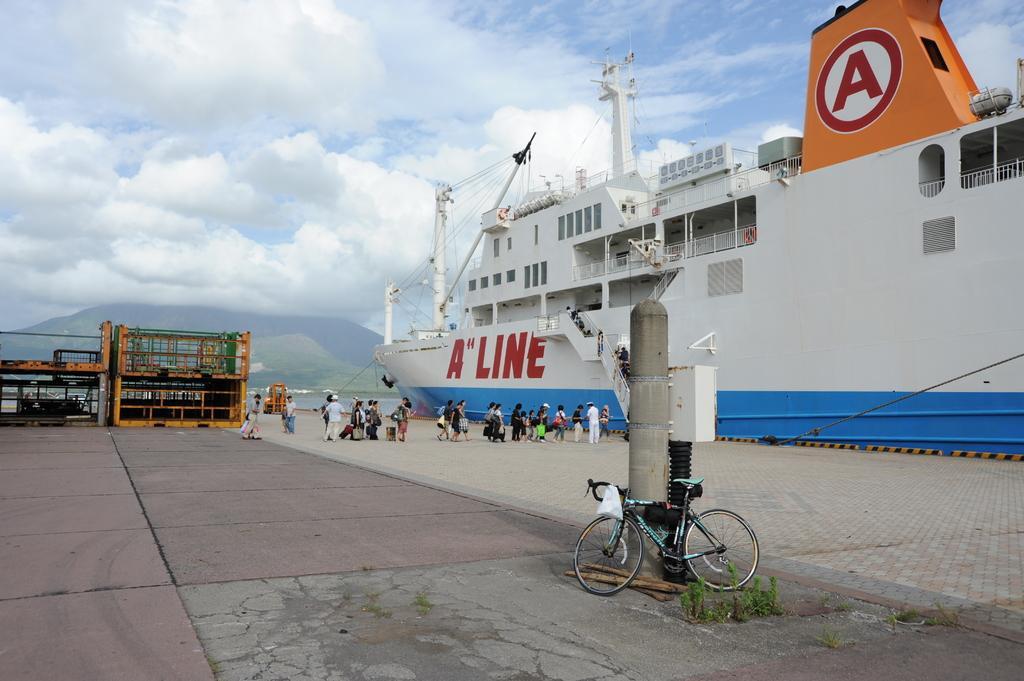How would you summarize this image in a sentence or two? In this picture we can see a bicycle in the front, in the background there are some people standing, on the right side we can see a ship, there is the sky at the top of the picture, we can see plants here, there is a pole here. 